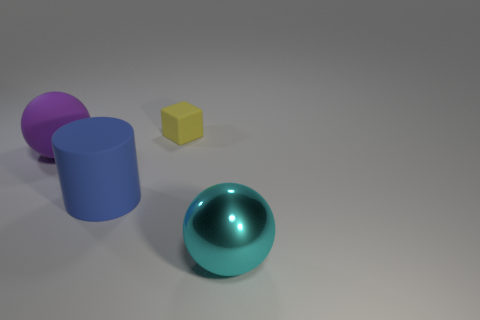What textures are visible on the different objects in the scene? The objects in the image display a variety of textures. The small yellow cube has a matte finish, providing a diffused reflection. The large blue cylinder appears to have a smooth surface with a slight satin sheen, while the purple object behind it has a soft rubber texture with a more muted light absorption. Lastly, the sphere in the foreground has a reflective, almost metallic texture, which mirrors the environment around it. 